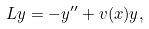<formula> <loc_0><loc_0><loc_500><loc_500>L y = - y ^ { \prime \prime } + v ( x ) y ,</formula> 